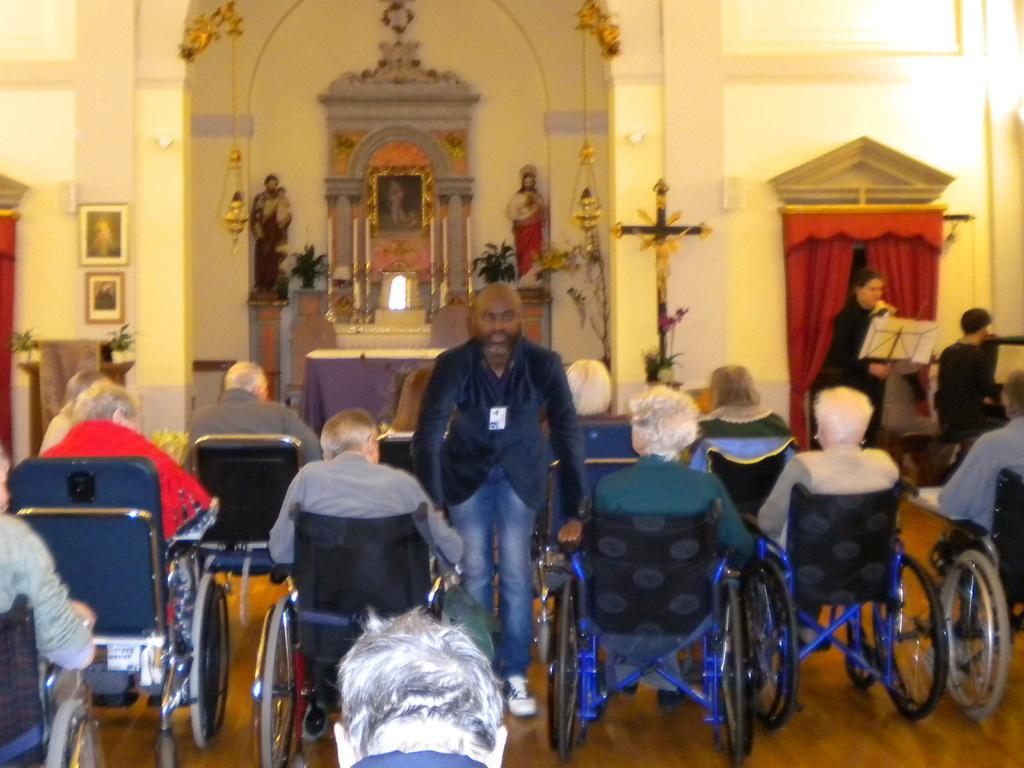Can you describe this image briefly? There are group of people sitting in the wheelchairs. Here is a person standing. I think this is a church. I can see two sculptures. This is a table covered with a cloth. This looks like a holy cross symbol. These are the frames, attached to the wall. Here is a person standing. I can see the curtains hanging to the hanger. This looks like an arch. 